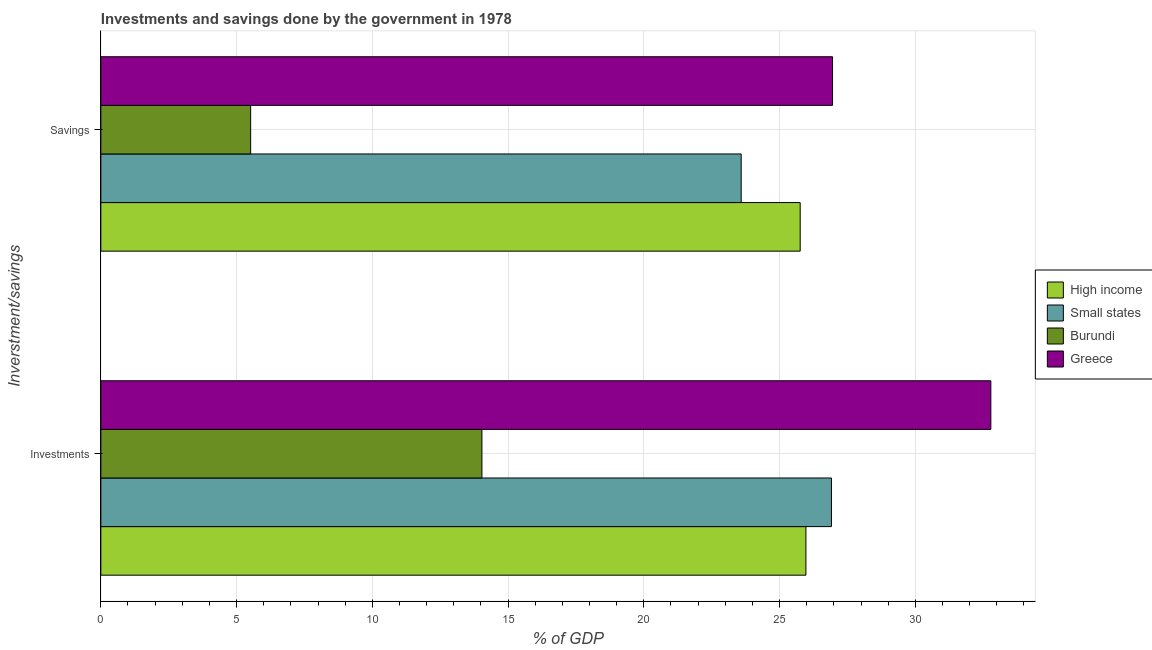How many bars are there on the 2nd tick from the top?
Ensure brevity in your answer.  4. What is the label of the 1st group of bars from the top?
Make the answer very short. Savings. What is the savings of government in Burundi?
Your response must be concise. 5.52. Across all countries, what is the maximum savings of government?
Give a very brief answer. 26.95. Across all countries, what is the minimum savings of government?
Your answer should be compact. 5.52. In which country was the savings of government maximum?
Your response must be concise. Greece. In which country was the savings of government minimum?
Offer a very short reply. Burundi. What is the total investments of government in the graph?
Your answer should be very brief. 99.7. What is the difference between the savings of government in Burundi and that in High income?
Make the answer very short. -20.24. What is the difference between the investments of government in Burundi and the savings of government in Greece?
Your answer should be very brief. -12.91. What is the average savings of government per country?
Ensure brevity in your answer.  20.45. What is the difference between the investments of government and savings of government in Burundi?
Ensure brevity in your answer.  8.52. What is the ratio of the investments of government in Greece to that in Small states?
Provide a short and direct response. 1.22. Is the investments of government in High income less than that in Small states?
Your response must be concise. Yes. In how many countries, is the investments of government greater than the average investments of government taken over all countries?
Your response must be concise. 3. How many bars are there?
Your answer should be very brief. 8. Are all the bars in the graph horizontal?
Give a very brief answer. Yes. Are the values on the major ticks of X-axis written in scientific E-notation?
Make the answer very short. No. Does the graph contain any zero values?
Your answer should be very brief. No. How are the legend labels stacked?
Offer a very short reply. Vertical. What is the title of the graph?
Provide a succinct answer. Investments and savings done by the government in 1978. Does "Costa Rica" appear as one of the legend labels in the graph?
Provide a short and direct response. No. What is the label or title of the X-axis?
Give a very brief answer. % of GDP. What is the label or title of the Y-axis?
Offer a very short reply. Inverstment/savings. What is the % of GDP of High income in Investments?
Keep it short and to the point. 25.97. What is the % of GDP of Small states in Investments?
Your answer should be compact. 26.91. What is the % of GDP in Burundi in Investments?
Your answer should be compact. 14.04. What is the % of GDP of Greece in Investments?
Ensure brevity in your answer.  32.78. What is the % of GDP in High income in Savings?
Give a very brief answer. 25.76. What is the % of GDP of Small states in Savings?
Your answer should be compact. 23.59. What is the % of GDP of Burundi in Savings?
Your response must be concise. 5.52. What is the % of GDP in Greece in Savings?
Your response must be concise. 26.95. Across all Inverstment/savings, what is the maximum % of GDP in High income?
Your answer should be very brief. 25.97. Across all Inverstment/savings, what is the maximum % of GDP of Small states?
Make the answer very short. 26.91. Across all Inverstment/savings, what is the maximum % of GDP of Burundi?
Your response must be concise. 14.04. Across all Inverstment/savings, what is the maximum % of GDP in Greece?
Give a very brief answer. 32.78. Across all Inverstment/savings, what is the minimum % of GDP of High income?
Ensure brevity in your answer.  25.76. Across all Inverstment/savings, what is the minimum % of GDP in Small states?
Your response must be concise. 23.59. Across all Inverstment/savings, what is the minimum % of GDP in Burundi?
Give a very brief answer. 5.52. Across all Inverstment/savings, what is the minimum % of GDP in Greece?
Give a very brief answer. 26.95. What is the total % of GDP in High income in the graph?
Offer a terse response. 51.73. What is the total % of GDP in Small states in the graph?
Offer a terse response. 50.5. What is the total % of GDP in Burundi in the graph?
Provide a succinct answer. 19.56. What is the total % of GDP in Greece in the graph?
Your answer should be very brief. 59.73. What is the difference between the % of GDP in High income in Investments and that in Savings?
Provide a short and direct response. 0.21. What is the difference between the % of GDP of Small states in Investments and that in Savings?
Provide a short and direct response. 3.33. What is the difference between the % of GDP in Burundi in Investments and that in Savings?
Your response must be concise. 8.52. What is the difference between the % of GDP of Greece in Investments and that in Savings?
Offer a terse response. 5.83. What is the difference between the % of GDP in High income in Investments and the % of GDP in Small states in Savings?
Provide a succinct answer. 2.38. What is the difference between the % of GDP of High income in Investments and the % of GDP of Burundi in Savings?
Your response must be concise. 20.45. What is the difference between the % of GDP in High income in Investments and the % of GDP in Greece in Savings?
Your response must be concise. -0.98. What is the difference between the % of GDP in Small states in Investments and the % of GDP in Burundi in Savings?
Give a very brief answer. 21.39. What is the difference between the % of GDP of Small states in Investments and the % of GDP of Greece in Savings?
Offer a terse response. -0.04. What is the difference between the % of GDP in Burundi in Investments and the % of GDP in Greece in Savings?
Keep it short and to the point. -12.91. What is the average % of GDP in High income per Inverstment/savings?
Give a very brief answer. 25.87. What is the average % of GDP of Small states per Inverstment/savings?
Offer a terse response. 25.25. What is the average % of GDP of Burundi per Inverstment/savings?
Give a very brief answer. 9.78. What is the average % of GDP in Greece per Inverstment/savings?
Your answer should be compact. 29.87. What is the difference between the % of GDP in High income and % of GDP in Small states in Investments?
Keep it short and to the point. -0.94. What is the difference between the % of GDP in High income and % of GDP in Burundi in Investments?
Ensure brevity in your answer.  11.93. What is the difference between the % of GDP of High income and % of GDP of Greece in Investments?
Give a very brief answer. -6.81. What is the difference between the % of GDP in Small states and % of GDP in Burundi in Investments?
Your answer should be compact. 12.87. What is the difference between the % of GDP of Small states and % of GDP of Greece in Investments?
Your response must be concise. -5.87. What is the difference between the % of GDP of Burundi and % of GDP of Greece in Investments?
Offer a terse response. -18.75. What is the difference between the % of GDP in High income and % of GDP in Small states in Savings?
Your response must be concise. 2.17. What is the difference between the % of GDP in High income and % of GDP in Burundi in Savings?
Ensure brevity in your answer.  20.24. What is the difference between the % of GDP in High income and % of GDP in Greece in Savings?
Keep it short and to the point. -1.19. What is the difference between the % of GDP of Small states and % of GDP of Burundi in Savings?
Make the answer very short. 18.07. What is the difference between the % of GDP in Small states and % of GDP in Greece in Savings?
Your response must be concise. -3.36. What is the difference between the % of GDP of Burundi and % of GDP of Greece in Savings?
Your answer should be very brief. -21.43. What is the ratio of the % of GDP in High income in Investments to that in Savings?
Keep it short and to the point. 1.01. What is the ratio of the % of GDP of Small states in Investments to that in Savings?
Your answer should be very brief. 1.14. What is the ratio of the % of GDP in Burundi in Investments to that in Savings?
Your answer should be very brief. 2.54. What is the ratio of the % of GDP in Greece in Investments to that in Savings?
Ensure brevity in your answer.  1.22. What is the difference between the highest and the second highest % of GDP of High income?
Keep it short and to the point. 0.21. What is the difference between the highest and the second highest % of GDP in Small states?
Keep it short and to the point. 3.33. What is the difference between the highest and the second highest % of GDP of Burundi?
Your answer should be very brief. 8.52. What is the difference between the highest and the second highest % of GDP in Greece?
Make the answer very short. 5.83. What is the difference between the highest and the lowest % of GDP in High income?
Provide a short and direct response. 0.21. What is the difference between the highest and the lowest % of GDP in Small states?
Provide a short and direct response. 3.33. What is the difference between the highest and the lowest % of GDP of Burundi?
Your answer should be compact. 8.52. What is the difference between the highest and the lowest % of GDP of Greece?
Ensure brevity in your answer.  5.83. 